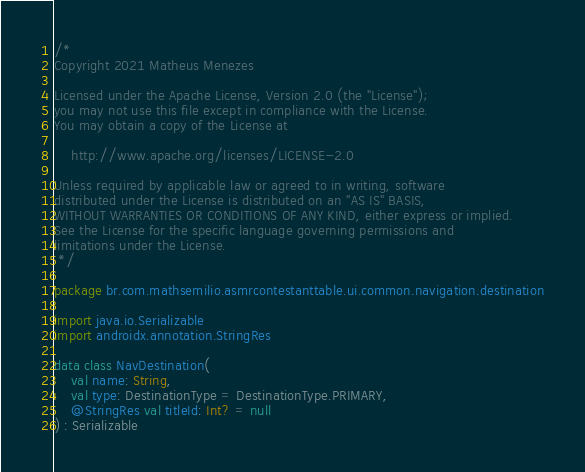<code> <loc_0><loc_0><loc_500><loc_500><_Kotlin_>/*
Copyright 2021 Matheus Menezes

Licensed under the Apache License, Version 2.0 (the "License");
you may not use this file except in compliance with the License.
You may obtain a copy of the License at

    http://www.apache.org/licenses/LICENSE-2.0

Unless required by applicable law or agreed to in writing, software
distributed under the License is distributed on an "AS IS" BASIS,
WITHOUT WARRANTIES OR CONDITIONS OF ANY KIND, either express or implied.
See the License for the specific language governing permissions and
limitations under the License.
 */

package br.com.mathsemilio.asmrcontestanttable.ui.common.navigation.destination

import java.io.Serializable
import androidx.annotation.StringRes

data class NavDestination(
    val name: String,
    val type: DestinationType = DestinationType.PRIMARY,
    @StringRes val titleId: Int? = null
) : Serializable
</code> 